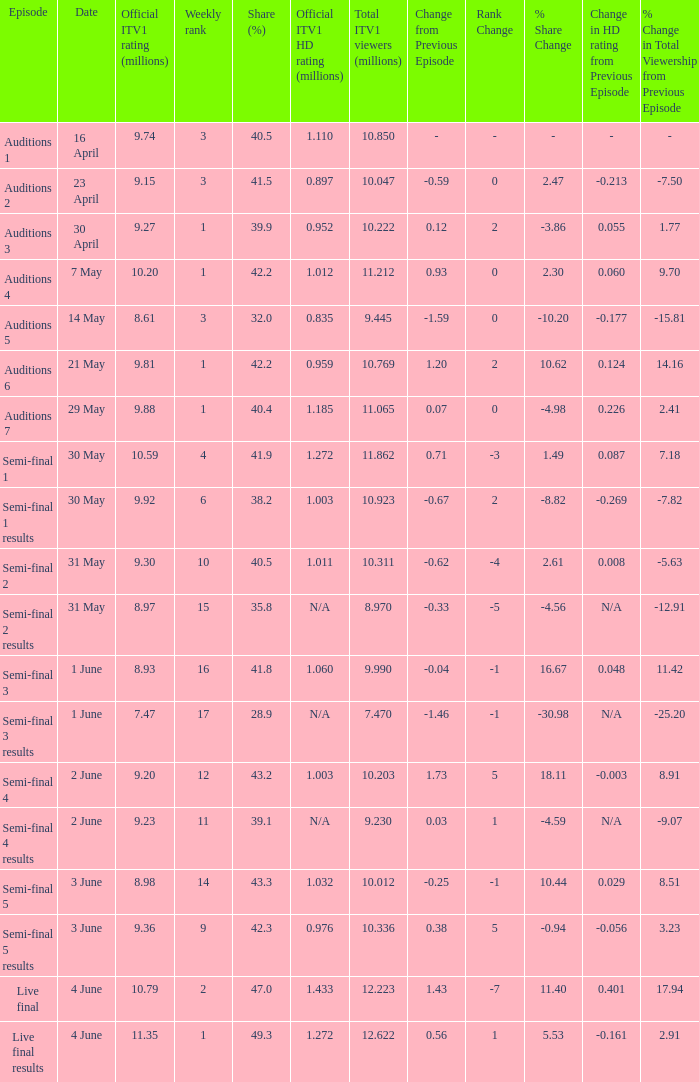What was the official itv1 audience size in millions for the live final results episode? 11.35. 